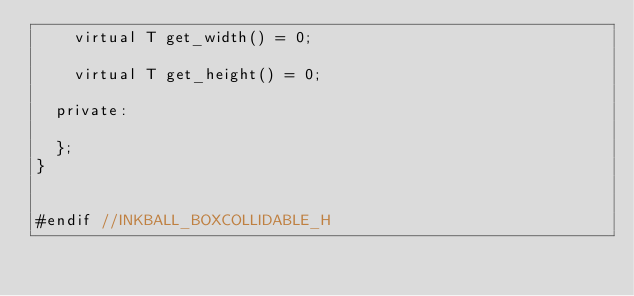Convert code to text. <code><loc_0><loc_0><loc_500><loc_500><_C_>		virtual T get_width() = 0;

		virtual T get_height() = 0;

	private:

	};
}


#endif //INKBALL_BOXCOLLIDABLE_H
</code> 